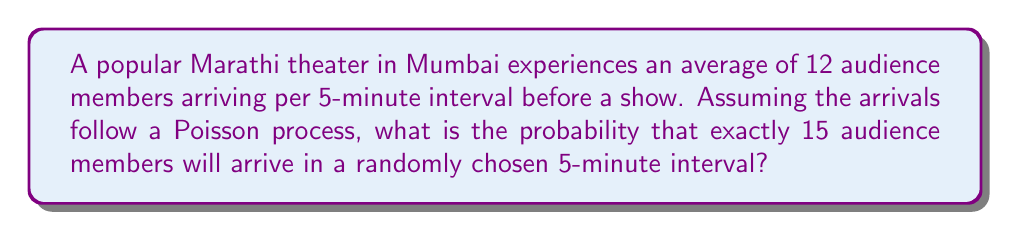Help me with this question. To solve this problem, we'll use the Poisson distribution formula:

$$P(X = k) = \frac{e^{-\lambda} \lambda^k}{k!}$$

Where:
$\lambda$ = average number of events in the interval
$k$ = number of events we're interested in
$e$ = Euler's number (approximately 2.71828)

Given:
- Average arrivals: 12 per 5-minute interval
- We want the probability of exactly 15 arrivals

Step 1: Identify $\lambda$ and $k$
$\lambda = 12$ (average arrivals per interval)
$k = 15$ (number of arrivals we're calculating the probability for)

Step 2: Plug values into the Poisson formula
$$P(X = 15) = \frac{e^{-12} 12^{15}}{15!}$$

Step 3: Calculate the numerator
$e^{-12} \approx 6.14421 \times 10^{-6}$
$12^{15} = 1.28577 \times 10^{16}$
Numerator $\approx 79.0001$

Step 4: Calculate the denominator
$15! = 1,307,674,368,000$

Step 5: Divide the numerator by the denominator
$$P(X = 15) \approx \frac{79.0001}{1,307,674,368,000} \approx 6.04129 \times 10^{-11}$$

Step 6: Convert to a percentage
$6.04129 \times 10^{-11} \times 100\% \approx 6.04129 \times 10^{-9}\%$
Answer: $6.04129 \times 10^{-9}\%$ 